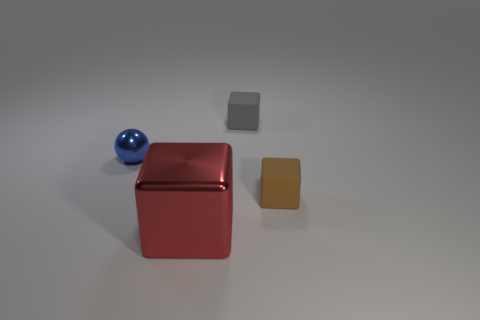Add 1 big red cubes. How many objects exist? 5 Subtract all tiny gray matte blocks. How many blocks are left? 2 Subtract all cubes. How many objects are left? 1 Subtract all blue cubes. Subtract all red cylinders. How many cubes are left? 3 Subtract all red cylinders. How many brown blocks are left? 1 Subtract all small blue metallic spheres. Subtract all small blocks. How many objects are left? 1 Add 4 spheres. How many spheres are left? 5 Add 4 gray things. How many gray things exist? 5 Subtract all gray blocks. How many blocks are left? 2 Subtract 1 blue balls. How many objects are left? 3 